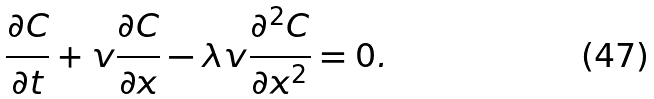Convert formula to latex. <formula><loc_0><loc_0><loc_500><loc_500>\frac { \partial C } { \partial t } + v \frac { \partial C } { \partial x } - \lambda v \frac { \partial ^ { 2 } C } { \partial x ^ { 2 } } = 0 .</formula> 